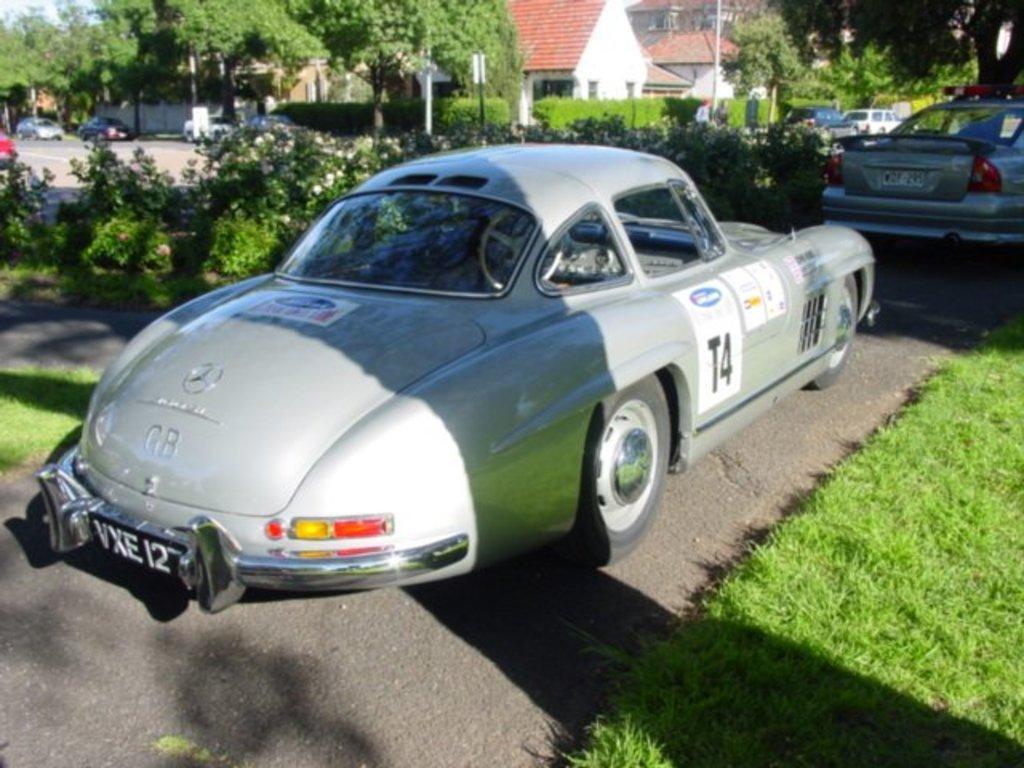Please provide a concise description of this image. In this image we can see buildings, motor vehicles on the road, plants, shrubs, grass, street poles, trees, information boards and sky. 